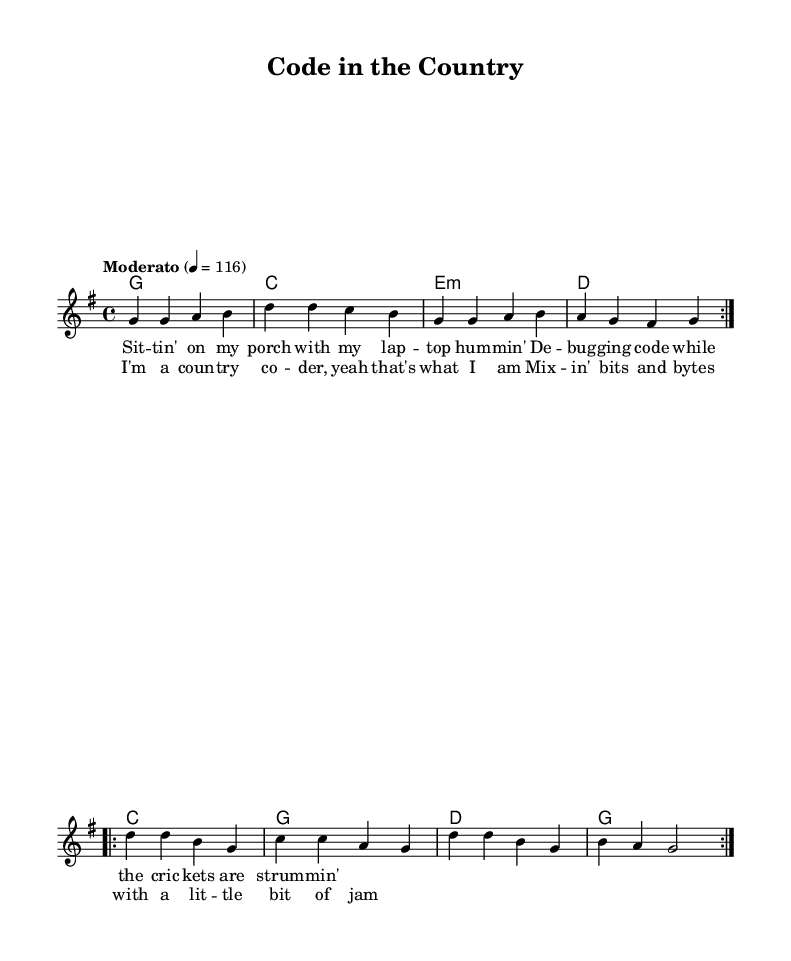What is the key signature of this music? The key signature is G major, which has one sharp (F#). In the global section of the code, the declaration `\key g \major` indicates this.
Answer: G major What is the time signature of the piece? The time signature is 4/4, as indicated by `\time 4/4` in the global section. This means there are four beats in each measure.
Answer: 4/4 What is the tempo marking of the music? The tempo marking is "Moderato," which typically suggests a moderate speed. This is noted in the global section with `\tempo "Moderato" 4 = 116.` This indicates a tempo of 116 beats per minute.
Answer: Moderato How many measures are in the melody? The melody contains eight measures. This can be determined by counting the repeat structures in the melody code, where it states `\repeat volta 2` and shows sequences totaling eight distinct measures.
Answer: Eight Which musical form does this piece use? The piece follows a verse-chorus form, which is common in Country Rock music. It can be determined from the structure of the lyrics in the code, with a verse followed by a chorus section.
Answer: Verse-chorus What style does the piece exemplify? The piece exemplifies a fusion of country and rock elements, often found in Country Rock genre. This can be inferred from the title and lyrics that mention coding and a laid-back country lifestyle, blending technological themes with traditional music forms.
Answer: Country Rock 